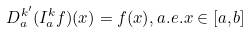<formula> <loc_0><loc_0><loc_500><loc_500>D _ { a } ^ { k ^ { \prime } } ( I _ { a } ^ { k } f ) ( x ) = f ( x ) , a . e . x \in [ a , b ]</formula> 